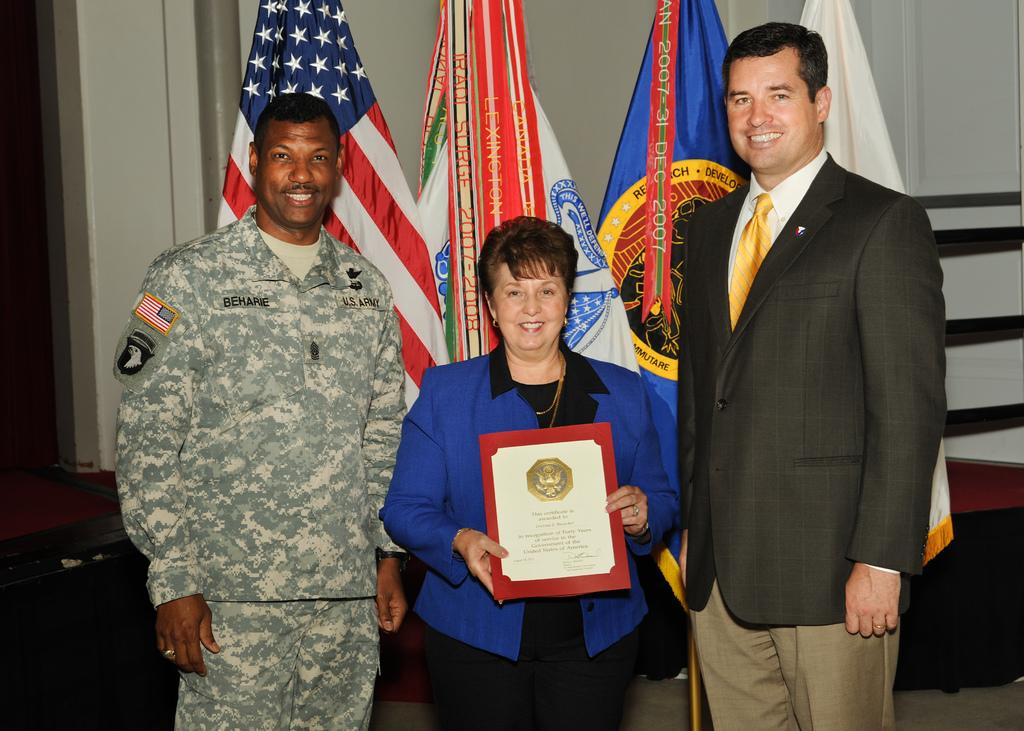How many people are in the image? There are two men and a woman in the image. What is the woman holding in the image? The woman is holding a certificate. What can be seen in the background of the image? There are flags in the background of the image. What is visible behind the people in the image? There is a wall visible in the image. How many boots are visible on the men in the image? There is no mention of boots in the image, so we cannot determine how many boots are visible. What type of arm is the woman using to hold the certificate? The image does not specify the type of arm the woman is using to hold the certificate, but it is likely her hand. 